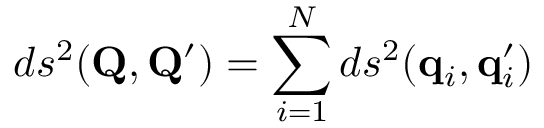Convert formula to latex. <formula><loc_0><loc_0><loc_500><loc_500>d s ^ { 2 } ( Q , Q ^ { \prime } ) = \sum _ { i = 1 } ^ { N } d s ^ { 2 } ( q _ { i } , q _ { i } ^ { \prime } )</formula> 